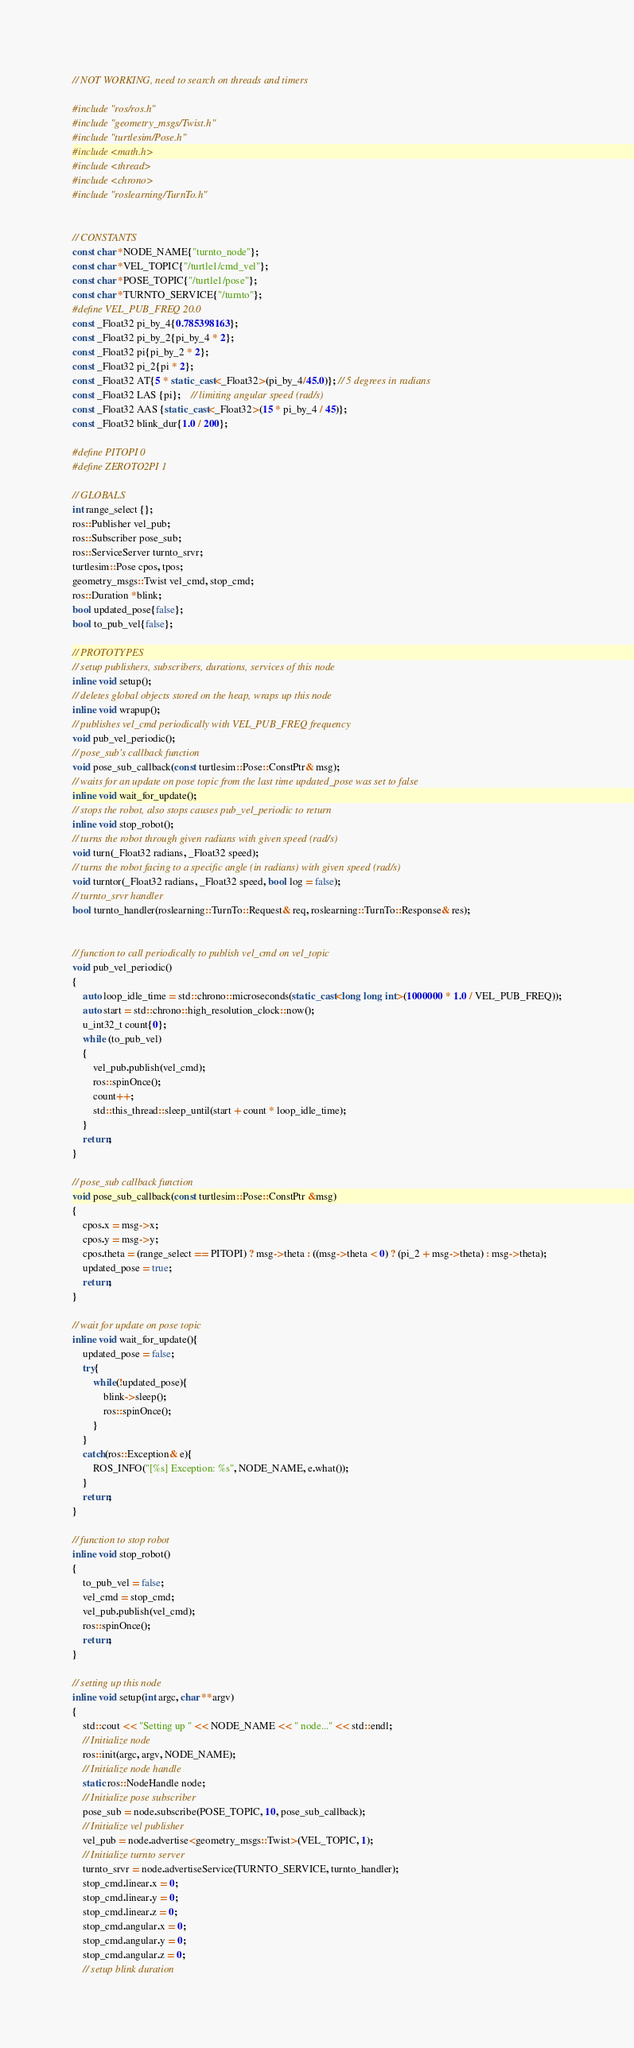Convert code to text. <code><loc_0><loc_0><loc_500><loc_500><_C++_>// NOT WORKING, need to search on threads and timers

#include "ros/ros.h"
#include "geometry_msgs/Twist.h"
#include "turtlesim/Pose.h"
#include <math.h>
#include <thread>
#include <chrono>
#include "roslearning/TurnTo.h"


// CONSTANTS
const char *NODE_NAME{"turnto_node"};
const char *VEL_TOPIC{"/turtle1/cmd_vel"};
const char *POSE_TOPIC{"/turtle1/pose"};
const char *TURNTO_SERVICE{"/turnto"};
#define VEL_PUB_FREQ 20.0
const _Float32 pi_by_4{0.785398163};
const _Float32 pi_by_2{pi_by_4 * 2};
const _Float32 pi{pi_by_2 * 2};
const _Float32 pi_2{pi * 2};
const _Float32 AT{5 * static_cast<_Float32>(pi_by_4/45.0)}; // 5 degrees in radians
const _Float32 LAS {pi};    // limiting angular speed (rad/s)
const _Float32 AAS {static_cast<_Float32>(15 * pi_by_4 / 45)};
const _Float32 blink_dur{1.0 / 200};

#define PITOPI 0
#define ZEROTO2PI 1

// GLOBALS
int range_select {};
ros::Publisher vel_pub;
ros::Subscriber pose_sub;
ros::ServiceServer turnto_srvr;
turtlesim::Pose cpos, tpos;
geometry_msgs::Twist vel_cmd, stop_cmd;
ros::Duration *blink;
bool updated_pose{false};
bool to_pub_vel{false};

// PROTOTYPES
// setup publishers, subscribers, durations, services of this node
inline void setup();
// deletes global objects stored on the heap, wraps up this node
inline void wrapup();
// publishes vel_cmd periodically with VEL_PUB_FREQ frequency
void pub_vel_periodic();
// pose_sub's callback function
void pose_sub_callback(const turtlesim::Pose::ConstPtr& msg);
// waits for an update on pose topic from the last time updated_pose was set to false
inline void wait_for_update();
// stops the robot, also stops causes pub_vel_periodic to return
inline void stop_robot();
// turns the robot through given radians with given speed (rad/s)
void turn(_Float32 radians, _Float32 speed);
// turns the robot facing to a specific angle (in radians) with given speed (rad/s)
void turntor(_Float32 radians, _Float32 speed, bool log = false);
// turnto_srvr handler
bool turnto_handler(roslearning::TurnTo::Request& req, roslearning::TurnTo::Response& res);


// function to call periodically to publish vel_cmd on vel_topic
void pub_vel_periodic()
{
    auto loop_idle_time = std::chrono::microseconds(static_cast<long long int>(1000000 * 1.0 / VEL_PUB_FREQ));
    auto start = std::chrono::high_resolution_clock::now();
    u_int32_t count{0};
    while (to_pub_vel)
    {
        vel_pub.publish(vel_cmd);
        ros::spinOnce();
        count++;
        std::this_thread::sleep_until(start + count * loop_idle_time);
    }
    return;
}

// pose_sub callback function
void pose_sub_callback(const turtlesim::Pose::ConstPtr &msg)
{
    cpos.x = msg->x;
    cpos.y = msg->y;
    cpos.theta = (range_select == PITOPI) ? msg->theta : ((msg->theta < 0) ? (pi_2 + msg->theta) : msg->theta);
    updated_pose = true;
    return;
}

// wait for update on pose topic
inline void wait_for_update(){
    updated_pose = false;
    try{
        while(!updated_pose){
            blink->sleep();
            ros::spinOnce();
        }
    }
    catch(ros::Exception& e){
        ROS_INFO("[%s] Exception: %s", NODE_NAME, e.what());
    }
    return;
}

// function to stop robot
inline void stop_robot()
{
    to_pub_vel = false;
    vel_cmd = stop_cmd;
    vel_pub.publish(vel_cmd);
    ros::spinOnce();
    return;
}

// setting up this node
inline void setup(int argc, char **argv)
{
    std::cout << "Setting up " << NODE_NAME << " node..." << std::endl;
    // Initialize node
    ros::init(argc, argv, NODE_NAME);
    // Initialize node handle
    static ros::NodeHandle node;
    // Initialize pose subscriber
    pose_sub = node.subscribe(POSE_TOPIC, 10, pose_sub_callback);
    // Initialize vel publisher
    vel_pub = node.advertise<geometry_msgs::Twist>(VEL_TOPIC, 1);
    // Initialize turnto server
    turnto_srvr = node.advertiseService(TURNTO_SERVICE, turnto_handler);
    stop_cmd.linear.x = 0;
    stop_cmd.linear.y = 0;
    stop_cmd.linear.z = 0;
    stop_cmd.angular.x = 0;
    stop_cmd.angular.y = 0;
    stop_cmd.angular.z = 0;
    // setup blink duration</code> 